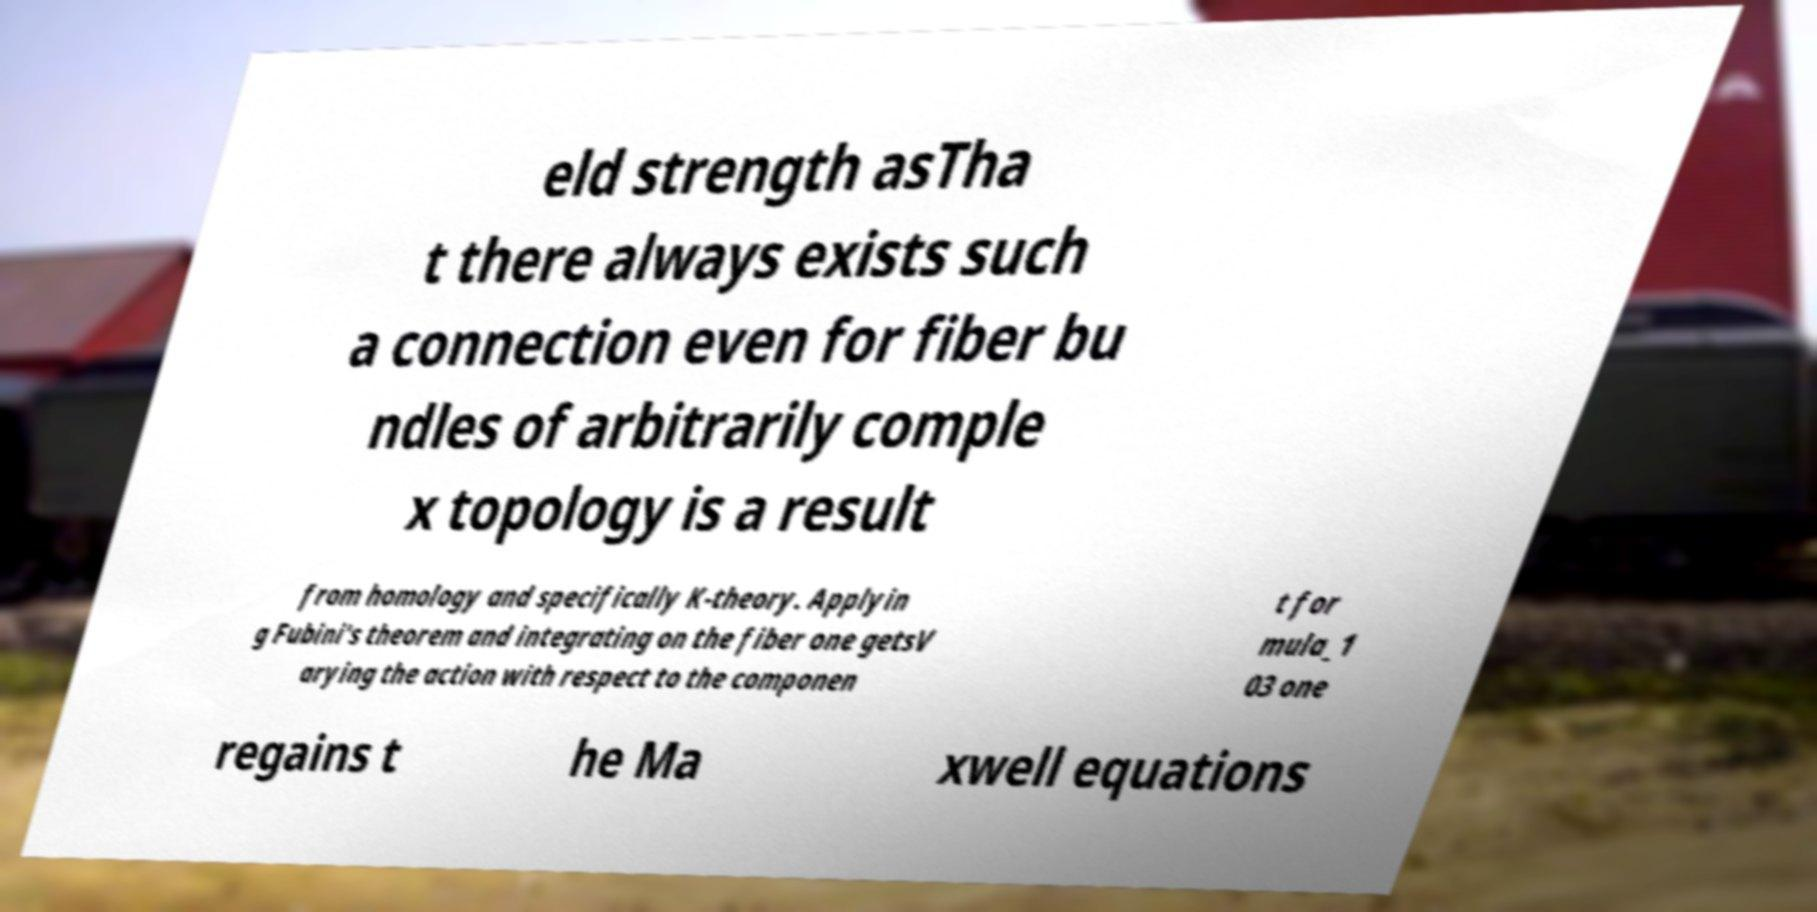What messages or text are displayed in this image? I need them in a readable, typed format. eld strength asTha t there always exists such a connection even for fiber bu ndles of arbitrarily comple x topology is a result from homology and specifically K-theory. Applyin g Fubini's theorem and integrating on the fiber one getsV arying the action with respect to the componen t for mula_1 03 one regains t he Ma xwell equations 